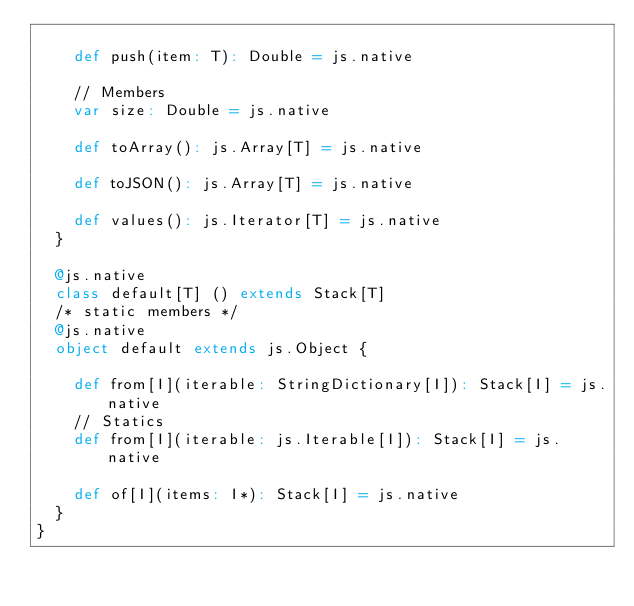<code> <loc_0><loc_0><loc_500><loc_500><_Scala_>    
    def push(item: T): Double = js.native
    
    // Members
    var size: Double = js.native
    
    def toArray(): js.Array[T] = js.native
    
    def toJSON(): js.Array[T] = js.native
    
    def values(): js.Iterator[T] = js.native
  }
  
  @js.native
  class default[T] () extends Stack[T]
  /* static members */
  @js.native
  object default extends js.Object {
    
    def from[I](iterable: StringDictionary[I]): Stack[I] = js.native
    // Statics
    def from[I](iterable: js.Iterable[I]): Stack[I] = js.native
    
    def of[I](items: I*): Stack[I] = js.native
  }
}
</code> 